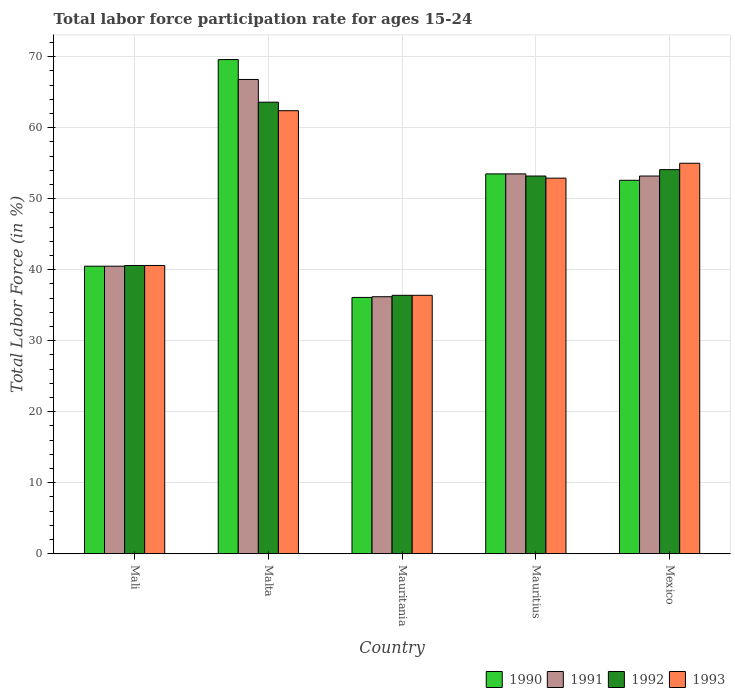Are the number of bars per tick equal to the number of legend labels?
Keep it short and to the point. Yes. How many bars are there on the 2nd tick from the left?
Give a very brief answer. 4. What is the label of the 1st group of bars from the left?
Keep it short and to the point. Mali. In how many cases, is the number of bars for a given country not equal to the number of legend labels?
Keep it short and to the point. 0. What is the labor force participation rate in 1991 in Malta?
Keep it short and to the point. 66.8. Across all countries, what is the maximum labor force participation rate in 1993?
Offer a terse response. 62.4. Across all countries, what is the minimum labor force participation rate in 1993?
Ensure brevity in your answer.  36.4. In which country was the labor force participation rate in 1990 maximum?
Provide a succinct answer. Malta. In which country was the labor force participation rate in 1991 minimum?
Offer a very short reply. Mauritania. What is the total labor force participation rate in 1992 in the graph?
Keep it short and to the point. 247.9. What is the difference between the labor force participation rate in 1990 in Mauritius and the labor force participation rate in 1992 in Mali?
Ensure brevity in your answer.  12.9. What is the average labor force participation rate in 1991 per country?
Provide a succinct answer. 50.04. What is the difference between the labor force participation rate of/in 1990 and labor force participation rate of/in 1993 in Mexico?
Give a very brief answer. -2.4. What is the ratio of the labor force participation rate in 1990 in Mali to that in Malta?
Your response must be concise. 0.58. Is the labor force participation rate in 1992 in Malta less than that in Mexico?
Offer a terse response. No. Is the difference between the labor force participation rate in 1990 in Mali and Malta greater than the difference between the labor force participation rate in 1993 in Mali and Malta?
Your answer should be very brief. No. What is the difference between the highest and the second highest labor force participation rate in 1992?
Offer a terse response. -0.9. What is the difference between the highest and the lowest labor force participation rate in 1990?
Give a very brief answer. 33.5. Is the sum of the labor force participation rate in 1991 in Mali and Mauritius greater than the maximum labor force participation rate in 1993 across all countries?
Your answer should be compact. Yes. Is it the case that in every country, the sum of the labor force participation rate in 1991 and labor force participation rate in 1992 is greater than the sum of labor force participation rate in 1990 and labor force participation rate in 1993?
Ensure brevity in your answer.  No. What does the 3rd bar from the left in Mauritania represents?
Provide a short and direct response. 1992. What does the 1st bar from the right in Mali represents?
Your answer should be compact. 1993. Is it the case that in every country, the sum of the labor force participation rate in 1991 and labor force participation rate in 1993 is greater than the labor force participation rate in 1990?
Keep it short and to the point. Yes. Are all the bars in the graph horizontal?
Keep it short and to the point. No. How many countries are there in the graph?
Offer a terse response. 5. What is the difference between two consecutive major ticks on the Y-axis?
Provide a short and direct response. 10. Are the values on the major ticks of Y-axis written in scientific E-notation?
Your response must be concise. No. Where does the legend appear in the graph?
Offer a terse response. Bottom right. How many legend labels are there?
Offer a very short reply. 4. How are the legend labels stacked?
Offer a very short reply. Horizontal. What is the title of the graph?
Offer a very short reply. Total labor force participation rate for ages 15-24. Does "1975" appear as one of the legend labels in the graph?
Your answer should be very brief. No. What is the Total Labor Force (in %) in 1990 in Mali?
Provide a succinct answer. 40.5. What is the Total Labor Force (in %) in 1991 in Mali?
Offer a terse response. 40.5. What is the Total Labor Force (in %) of 1992 in Mali?
Offer a terse response. 40.6. What is the Total Labor Force (in %) of 1993 in Mali?
Your answer should be compact. 40.6. What is the Total Labor Force (in %) in 1990 in Malta?
Your response must be concise. 69.6. What is the Total Labor Force (in %) in 1991 in Malta?
Give a very brief answer. 66.8. What is the Total Labor Force (in %) in 1992 in Malta?
Your answer should be very brief. 63.6. What is the Total Labor Force (in %) in 1993 in Malta?
Give a very brief answer. 62.4. What is the Total Labor Force (in %) in 1990 in Mauritania?
Make the answer very short. 36.1. What is the Total Labor Force (in %) of 1991 in Mauritania?
Give a very brief answer. 36.2. What is the Total Labor Force (in %) in 1992 in Mauritania?
Provide a succinct answer. 36.4. What is the Total Labor Force (in %) in 1993 in Mauritania?
Offer a very short reply. 36.4. What is the Total Labor Force (in %) in 1990 in Mauritius?
Give a very brief answer. 53.5. What is the Total Labor Force (in %) in 1991 in Mauritius?
Provide a succinct answer. 53.5. What is the Total Labor Force (in %) in 1992 in Mauritius?
Your response must be concise. 53.2. What is the Total Labor Force (in %) in 1993 in Mauritius?
Ensure brevity in your answer.  52.9. What is the Total Labor Force (in %) of 1990 in Mexico?
Provide a short and direct response. 52.6. What is the Total Labor Force (in %) of 1991 in Mexico?
Ensure brevity in your answer.  53.2. What is the Total Labor Force (in %) of 1992 in Mexico?
Ensure brevity in your answer.  54.1. Across all countries, what is the maximum Total Labor Force (in %) of 1990?
Ensure brevity in your answer.  69.6. Across all countries, what is the maximum Total Labor Force (in %) in 1991?
Make the answer very short. 66.8. Across all countries, what is the maximum Total Labor Force (in %) of 1992?
Offer a very short reply. 63.6. Across all countries, what is the maximum Total Labor Force (in %) in 1993?
Provide a succinct answer. 62.4. Across all countries, what is the minimum Total Labor Force (in %) of 1990?
Provide a short and direct response. 36.1. Across all countries, what is the minimum Total Labor Force (in %) in 1991?
Make the answer very short. 36.2. Across all countries, what is the minimum Total Labor Force (in %) of 1992?
Make the answer very short. 36.4. Across all countries, what is the minimum Total Labor Force (in %) of 1993?
Your response must be concise. 36.4. What is the total Total Labor Force (in %) in 1990 in the graph?
Provide a short and direct response. 252.3. What is the total Total Labor Force (in %) in 1991 in the graph?
Offer a terse response. 250.2. What is the total Total Labor Force (in %) of 1992 in the graph?
Offer a terse response. 247.9. What is the total Total Labor Force (in %) in 1993 in the graph?
Your response must be concise. 247.3. What is the difference between the Total Labor Force (in %) of 1990 in Mali and that in Malta?
Your answer should be compact. -29.1. What is the difference between the Total Labor Force (in %) in 1991 in Mali and that in Malta?
Offer a terse response. -26.3. What is the difference between the Total Labor Force (in %) in 1992 in Mali and that in Malta?
Provide a succinct answer. -23. What is the difference between the Total Labor Force (in %) of 1993 in Mali and that in Malta?
Your response must be concise. -21.8. What is the difference between the Total Labor Force (in %) of 1990 in Mali and that in Mauritania?
Keep it short and to the point. 4.4. What is the difference between the Total Labor Force (in %) in 1991 in Mali and that in Mauritania?
Ensure brevity in your answer.  4.3. What is the difference between the Total Labor Force (in %) in 1993 in Mali and that in Mauritania?
Your response must be concise. 4.2. What is the difference between the Total Labor Force (in %) of 1992 in Mali and that in Mauritius?
Provide a short and direct response. -12.6. What is the difference between the Total Labor Force (in %) in 1990 in Mali and that in Mexico?
Ensure brevity in your answer.  -12.1. What is the difference between the Total Labor Force (in %) in 1993 in Mali and that in Mexico?
Your response must be concise. -14.4. What is the difference between the Total Labor Force (in %) in 1990 in Malta and that in Mauritania?
Your answer should be compact. 33.5. What is the difference between the Total Labor Force (in %) of 1991 in Malta and that in Mauritania?
Provide a succinct answer. 30.6. What is the difference between the Total Labor Force (in %) in 1992 in Malta and that in Mauritania?
Your answer should be compact. 27.2. What is the difference between the Total Labor Force (in %) of 1993 in Malta and that in Mauritania?
Keep it short and to the point. 26. What is the difference between the Total Labor Force (in %) of 1991 in Malta and that in Mauritius?
Your answer should be compact. 13.3. What is the difference between the Total Labor Force (in %) of 1990 in Malta and that in Mexico?
Make the answer very short. 17. What is the difference between the Total Labor Force (in %) of 1991 in Malta and that in Mexico?
Offer a terse response. 13.6. What is the difference between the Total Labor Force (in %) of 1992 in Malta and that in Mexico?
Your response must be concise. 9.5. What is the difference between the Total Labor Force (in %) of 1993 in Malta and that in Mexico?
Offer a terse response. 7.4. What is the difference between the Total Labor Force (in %) in 1990 in Mauritania and that in Mauritius?
Your answer should be compact. -17.4. What is the difference between the Total Labor Force (in %) of 1991 in Mauritania and that in Mauritius?
Offer a very short reply. -17.3. What is the difference between the Total Labor Force (in %) in 1992 in Mauritania and that in Mauritius?
Provide a succinct answer. -16.8. What is the difference between the Total Labor Force (in %) of 1993 in Mauritania and that in Mauritius?
Offer a very short reply. -16.5. What is the difference between the Total Labor Force (in %) of 1990 in Mauritania and that in Mexico?
Provide a succinct answer. -16.5. What is the difference between the Total Labor Force (in %) of 1992 in Mauritania and that in Mexico?
Offer a terse response. -17.7. What is the difference between the Total Labor Force (in %) of 1993 in Mauritania and that in Mexico?
Offer a terse response. -18.6. What is the difference between the Total Labor Force (in %) of 1991 in Mauritius and that in Mexico?
Ensure brevity in your answer.  0.3. What is the difference between the Total Labor Force (in %) in 1990 in Mali and the Total Labor Force (in %) in 1991 in Malta?
Your response must be concise. -26.3. What is the difference between the Total Labor Force (in %) in 1990 in Mali and the Total Labor Force (in %) in 1992 in Malta?
Provide a short and direct response. -23.1. What is the difference between the Total Labor Force (in %) of 1990 in Mali and the Total Labor Force (in %) of 1993 in Malta?
Provide a short and direct response. -21.9. What is the difference between the Total Labor Force (in %) in 1991 in Mali and the Total Labor Force (in %) in 1992 in Malta?
Give a very brief answer. -23.1. What is the difference between the Total Labor Force (in %) of 1991 in Mali and the Total Labor Force (in %) of 1993 in Malta?
Your answer should be very brief. -21.9. What is the difference between the Total Labor Force (in %) in 1992 in Mali and the Total Labor Force (in %) in 1993 in Malta?
Provide a short and direct response. -21.8. What is the difference between the Total Labor Force (in %) in 1990 in Mali and the Total Labor Force (in %) in 1992 in Mauritania?
Your answer should be very brief. 4.1. What is the difference between the Total Labor Force (in %) in 1990 in Mali and the Total Labor Force (in %) in 1993 in Mauritania?
Offer a very short reply. 4.1. What is the difference between the Total Labor Force (in %) in 1991 in Mali and the Total Labor Force (in %) in 1993 in Mauritania?
Your response must be concise. 4.1. What is the difference between the Total Labor Force (in %) in 1992 in Mali and the Total Labor Force (in %) in 1993 in Mauritania?
Offer a terse response. 4.2. What is the difference between the Total Labor Force (in %) in 1990 in Mali and the Total Labor Force (in %) in 1993 in Mauritius?
Give a very brief answer. -12.4. What is the difference between the Total Labor Force (in %) of 1992 in Mali and the Total Labor Force (in %) of 1993 in Mauritius?
Make the answer very short. -12.3. What is the difference between the Total Labor Force (in %) of 1990 in Mali and the Total Labor Force (in %) of 1991 in Mexico?
Give a very brief answer. -12.7. What is the difference between the Total Labor Force (in %) in 1991 in Mali and the Total Labor Force (in %) in 1992 in Mexico?
Offer a very short reply. -13.6. What is the difference between the Total Labor Force (in %) of 1992 in Mali and the Total Labor Force (in %) of 1993 in Mexico?
Offer a very short reply. -14.4. What is the difference between the Total Labor Force (in %) of 1990 in Malta and the Total Labor Force (in %) of 1991 in Mauritania?
Your answer should be very brief. 33.4. What is the difference between the Total Labor Force (in %) in 1990 in Malta and the Total Labor Force (in %) in 1992 in Mauritania?
Ensure brevity in your answer.  33.2. What is the difference between the Total Labor Force (in %) of 1990 in Malta and the Total Labor Force (in %) of 1993 in Mauritania?
Your response must be concise. 33.2. What is the difference between the Total Labor Force (in %) in 1991 in Malta and the Total Labor Force (in %) in 1992 in Mauritania?
Keep it short and to the point. 30.4. What is the difference between the Total Labor Force (in %) of 1991 in Malta and the Total Labor Force (in %) of 1993 in Mauritania?
Your answer should be very brief. 30.4. What is the difference between the Total Labor Force (in %) of 1992 in Malta and the Total Labor Force (in %) of 1993 in Mauritania?
Your response must be concise. 27.2. What is the difference between the Total Labor Force (in %) of 1990 in Malta and the Total Labor Force (in %) of 1991 in Mauritius?
Your answer should be compact. 16.1. What is the difference between the Total Labor Force (in %) of 1990 in Malta and the Total Labor Force (in %) of 1992 in Mauritius?
Make the answer very short. 16.4. What is the difference between the Total Labor Force (in %) in 1991 in Malta and the Total Labor Force (in %) in 1992 in Mauritius?
Provide a succinct answer. 13.6. What is the difference between the Total Labor Force (in %) in 1991 in Malta and the Total Labor Force (in %) in 1993 in Mauritius?
Ensure brevity in your answer.  13.9. What is the difference between the Total Labor Force (in %) of 1990 in Malta and the Total Labor Force (in %) of 1992 in Mexico?
Give a very brief answer. 15.5. What is the difference between the Total Labor Force (in %) in 1991 in Malta and the Total Labor Force (in %) in 1992 in Mexico?
Provide a short and direct response. 12.7. What is the difference between the Total Labor Force (in %) of 1992 in Malta and the Total Labor Force (in %) of 1993 in Mexico?
Your answer should be compact. 8.6. What is the difference between the Total Labor Force (in %) of 1990 in Mauritania and the Total Labor Force (in %) of 1991 in Mauritius?
Your answer should be compact. -17.4. What is the difference between the Total Labor Force (in %) in 1990 in Mauritania and the Total Labor Force (in %) in 1992 in Mauritius?
Your answer should be compact. -17.1. What is the difference between the Total Labor Force (in %) in 1990 in Mauritania and the Total Labor Force (in %) in 1993 in Mauritius?
Ensure brevity in your answer.  -16.8. What is the difference between the Total Labor Force (in %) of 1991 in Mauritania and the Total Labor Force (in %) of 1992 in Mauritius?
Make the answer very short. -17. What is the difference between the Total Labor Force (in %) of 1991 in Mauritania and the Total Labor Force (in %) of 1993 in Mauritius?
Your response must be concise. -16.7. What is the difference between the Total Labor Force (in %) of 1992 in Mauritania and the Total Labor Force (in %) of 1993 in Mauritius?
Offer a very short reply. -16.5. What is the difference between the Total Labor Force (in %) of 1990 in Mauritania and the Total Labor Force (in %) of 1991 in Mexico?
Offer a terse response. -17.1. What is the difference between the Total Labor Force (in %) in 1990 in Mauritania and the Total Labor Force (in %) in 1992 in Mexico?
Make the answer very short. -18. What is the difference between the Total Labor Force (in %) of 1990 in Mauritania and the Total Labor Force (in %) of 1993 in Mexico?
Offer a terse response. -18.9. What is the difference between the Total Labor Force (in %) of 1991 in Mauritania and the Total Labor Force (in %) of 1992 in Mexico?
Offer a terse response. -17.9. What is the difference between the Total Labor Force (in %) in 1991 in Mauritania and the Total Labor Force (in %) in 1993 in Mexico?
Offer a terse response. -18.8. What is the difference between the Total Labor Force (in %) in 1992 in Mauritania and the Total Labor Force (in %) in 1993 in Mexico?
Offer a very short reply. -18.6. What is the average Total Labor Force (in %) of 1990 per country?
Your answer should be very brief. 50.46. What is the average Total Labor Force (in %) of 1991 per country?
Your answer should be very brief. 50.04. What is the average Total Labor Force (in %) in 1992 per country?
Make the answer very short. 49.58. What is the average Total Labor Force (in %) in 1993 per country?
Offer a terse response. 49.46. What is the difference between the Total Labor Force (in %) of 1991 and Total Labor Force (in %) of 1992 in Mali?
Give a very brief answer. -0.1. What is the difference between the Total Labor Force (in %) of 1990 and Total Labor Force (in %) of 1991 in Malta?
Your answer should be very brief. 2.8. What is the difference between the Total Labor Force (in %) in 1991 and Total Labor Force (in %) in 1992 in Malta?
Your answer should be compact. 3.2. What is the difference between the Total Labor Force (in %) in 1992 and Total Labor Force (in %) in 1993 in Malta?
Make the answer very short. 1.2. What is the difference between the Total Labor Force (in %) of 1990 and Total Labor Force (in %) of 1993 in Mauritania?
Your answer should be compact. -0.3. What is the difference between the Total Labor Force (in %) of 1992 and Total Labor Force (in %) of 1993 in Mauritania?
Make the answer very short. 0. What is the difference between the Total Labor Force (in %) in 1991 and Total Labor Force (in %) in 1992 in Mauritius?
Your answer should be compact. 0.3. What is the difference between the Total Labor Force (in %) of 1991 and Total Labor Force (in %) of 1993 in Mauritius?
Provide a short and direct response. 0.6. What is the difference between the Total Labor Force (in %) in 1990 and Total Labor Force (in %) in 1991 in Mexico?
Make the answer very short. -0.6. What is the difference between the Total Labor Force (in %) in 1990 and Total Labor Force (in %) in 1992 in Mexico?
Make the answer very short. -1.5. What is the ratio of the Total Labor Force (in %) in 1990 in Mali to that in Malta?
Make the answer very short. 0.58. What is the ratio of the Total Labor Force (in %) of 1991 in Mali to that in Malta?
Offer a very short reply. 0.61. What is the ratio of the Total Labor Force (in %) of 1992 in Mali to that in Malta?
Offer a terse response. 0.64. What is the ratio of the Total Labor Force (in %) of 1993 in Mali to that in Malta?
Offer a very short reply. 0.65. What is the ratio of the Total Labor Force (in %) in 1990 in Mali to that in Mauritania?
Ensure brevity in your answer.  1.12. What is the ratio of the Total Labor Force (in %) of 1991 in Mali to that in Mauritania?
Offer a terse response. 1.12. What is the ratio of the Total Labor Force (in %) of 1992 in Mali to that in Mauritania?
Your response must be concise. 1.12. What is the ratio of the Total Labor Force (in %) of 1993 in Mali to that in Mauritania?
Your answer should be very brief. 1.12. What is the ratio of the Total Labor Force (in %) of 1990 in Mali to that in Mauritius?
Your answer should be compact. 0.76. What is the ratio of the Total Labor Force (in %) in 1991 in Mali to that in Mauritius?
Offer a terse response. 0.76. What is the ratio of the Total Labor Force (in %) of 1992 in Mali to that in Mauritius?
Offer a terse response. 0.76. What is the ratio of the Total Labor Force (in %) in 1993 in Mali to that in Mauritius?
Ensure brevity in your answer.  0.77. What is the ratio of the Total Labor Force (in %) of 1990 in Mali to that in Mexico?
Give a very brief answer. 0.77. What is the ratio of the Total Labor Force (in %) in 1991 in Mali to that in Mexico?
Give a very brief answer. 0.76. What is the ratio of the Total Labor Force (in %) in 1992 in Mali to that in Mexico?
Offer a terse response. 0.75. What is the ratio of the Total Labor Force (in %) in 1993 in Mali to that in Mexico?
Offer a terse response. 0.74. What is the ratio of the Total Labor Force (in %) in 1990 in Malta to that in Mauritania?
Provide a short and direct response. 1.93. What is the ratio of the Total Labor Force (in %) in 1991 in Malta to that in Mauritania?
Keep it short and to the point. 1.85. What is the ratio of the Total Labor Force (in %) in 1992 in Malta to that in Mauritania?
Your answer should be very brief. 1.75. What is the ratio of the Total Labor Force (in %) of 1993 in Malta to that in Mauritania?
Your answer should be compact. 1.71. What is the ratio of the Total Labor Force (in %) of 1990 in Malta to that in Mauritius?
Offer a terse response. 1.3. What is the ratio of the Total Labor Force (in %) in 1991 in Malta to that in Mauritius?
Your answer should be compact. 1.25. What is the ratio of the Total Labor Force (in %) of 1992 in Malta to that in Mauritius?
Give a very brief answer. 1.2. What is the ratio of the Total Labor Force (in %) of 1993 in Malta to that in Mauritius?
Offer a terse response. 1.18. What is the ratio of the Total Labor Force (in %) in 1990 in Malta to that in Mexico?
Offer a terse response. 1.32. What is the ratio of the Total Labor Force (in %) in 1991 in Malta to that in Mexico?
Provide a short and direct response. 1.26. What is the ratio of the Total Labor Force (in %) in 1992 in Malta to that in Mexico?
Ensure brevity in your answer.  1.18. What is the ratio of the Total Labor Force (in %) of 1993 in Malta to that in Mexico?
Ensure brevity in your answer.  1.13. What is the ratio of the Total Labor Force (in %) in 1990 in Mauritania to that in Mauritius?
Provide a short and direct response. 0.67. What is the ratio of the Total Labor Force (in %) in 1991 in Mauritania to that in Mauritius?
Your answer should be compact. 0.68. What is the ratio of the Total Labor Force (in %) of 1992 in Mauritania to that in Mauritius?
Make the answer very short. 0.68. What is the ratio of the Total Labor Force (in %) of 1993 in Mauritania to that in Mauritius?
Provide a succinct answer. 0.69. What is the ratio of the Total Labor Force (in %) in 1990 in Mauritania to that in Mexico?
Your answer should be compact. 0.69. What is the ratio of the Total Labor Force (in %) in 1991 in Mauritania to that in Mexico?
Provide a short and direct response. 0.68. What is the ratio of the Total Labor Force (in %) of 1992 in Mauritania to that in Mexico?
Provide a succinct answer. 0.67. What is the ratio of the Total Labor Force (in %) in 1993 in Mauritania to that in Mexico?
Make the answer very short. 0.66. What is the ratio of the Total Labor Force (in %) in 1990 in Mauritius to that in Mexico?
Make the answer very short. 1.02. What is the ratio of the Total Labor Force (in %) of 1991 in Mauritius to that in Mexico?
Keep it short and to the point. 1.01. What is the ratio of the Total Labor Force (in %) in 1992 in Mauritius to that in Mexico?
Provide a succinct answer. 0.98. What is the ratio of the Total Labor Force (in %) of 1993 in Mauritius to that in Mexico?
Your response must be concise. 0.96. What is the difference between the highest and the second highest Total Labor Force (in %) of 1990?
Give a very brief answer. 16.1. What is the difference between the highest and the lowest Total Labor Force (in %) of 1990?
Give a very brief answer. 33.5. What is the difference between the highest and the lowest Total Labor Force (in %) in 1991?
Offer a terse response. 30.6. What is the difference between the highest and the lowest Total Labor Force (in %) in 1992?
Your answer should be compact. 27.2. 